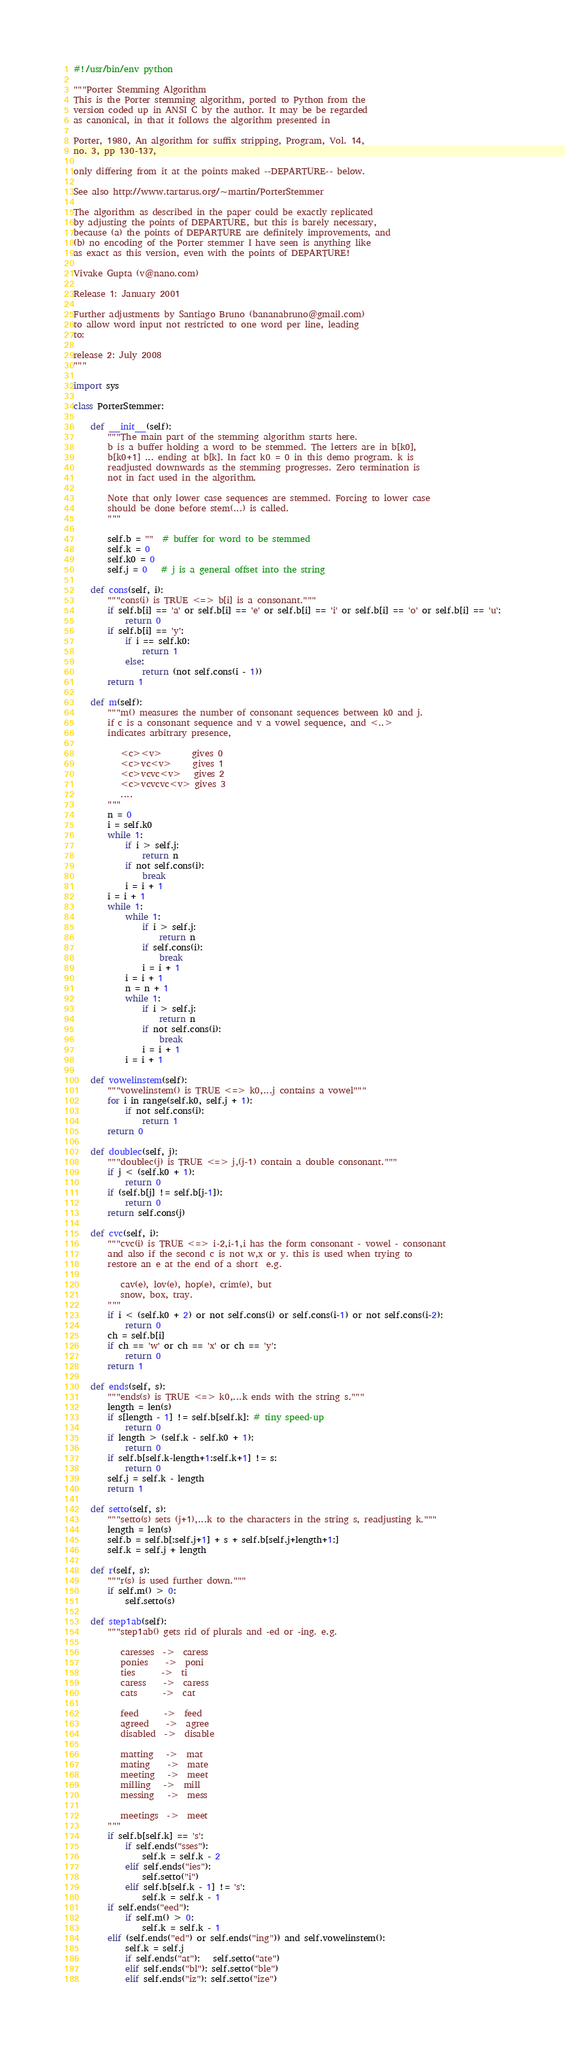Convert code to text. <code><loc_0><loc_0><loc_500><loc_500><_Python_>#!/usr/bin/env python

"""Porter Stemming Algorithm
This is the Porter stemming algorithm, ported to Python from the
version coded up in ANSI C by the author. It may be be regarded
as canonical, in that it follows the algorithm presented in

Porter, 1980, An algorithm for suffix stripping, Program, Vol. 14,
no. 3, pp 130-137,

only differing from it at the points maked --DEPARTURE-- below.

See also http://www.tartarus.org/~martin/PorterStemmer

The algorithm as described in the paper could be exactly replicated
by adjusting the points of DEPARTURE, but this is barely necessary,
because (a) the points of DEPARTURE are definitely improvements, and
(b) no encoding of the Porter stemmer I have seen is anything like
as exact as this version, even with the points of DEPARTURE!

Vivake Gupta (v@nano.com)

Release 1: January 2001

Further adjustments by Santiago Bruno (bananabruno@gmail.com)
to allow word input not restricted to one word per line, leading
to:

release 2: July 2008
"""

import sys

class PorterStemmer:

    def __init__(self):
        """The main part of the stemming algorithm starts here.
        b is a buffer holding a word to be stemmed. The letters are in b[k0],
        b[k0+1] ... ending at b[k]. In fact k0 = 0 in this demo program. k is
        readjusted downwards as the stemming progresses. Zero termination is
        not in fact used in the algorithm.

        Note that only lower case sequences are stemmed. Forcing to lower case
        should be done before stem(...) is called.
        """

        self.b = ""  # buffer for word to be stemmed
        self.k = 0
        self.k0 = 0
        self.j = 0   # j is a general offset into the string

    def cons(self, i):
        """cons(i) is TRUE <=> b[i] is a consonant."""
        if self.b[i] == 'a' or self.b[i] == 'e' or self.b[i] == 'i' or self.b[i] == 'o' or self.b[i] == 'u':
            return 0
        if self.b[i] == 'y':
            if i == self.k0:
                return 1
            else:
                return (not self.cons(i - 1))
        return 1

    def m(self):
        """m() measures the number of consonant sequences between k0 and j.
        if c is a consonant sequence and v a vowel sequence, and <..>
        indicates arbitrary presence,

           <c><v>       gives 0
           <c>vc<v>     gives 1
           <c>vcvc<v>   gives 2
           <c>vcvcvc<v> gives 3
           ....
        """
        n = 0
        i = self.k0
        while 1:
            if i > self.j:
                return n
            if not self.cons(i):
                break
            i = i + 1
        i = i + 1
        while 1:
            while 1:
                if i > self.j:
                    return n
                if self.cons(i):
                    break
                i = i + 1
            i = i + 1
            n = n + 1
            while 1:
                if i > self.j:
                    return n
                if not self.cons(i):
                    break
                i = i + 1
            i = i + 1

    def vowelinstem(self):
        """vowelinstem() is TRUE <=> k0,...j contains a vowel"""
        for i in range(self.k0, self.j + 1):
            if not self.cons(i):
                return 1
        return 0

    def doublec(self, j):
        """doublec(j) is TRUE <=> j,(j-1) contain a double consonant."""
        if j < (self.k0 + 1):
            return 0
        if (self.b[j] != self.b[j-1]):
            return 0
        return self.cons(j)

    def cvc(self, i):
        """cvc(i) is TRUE <=> i-2,i-1,i has the form consonant - vowel - consonant
        and also if the second c is not w,x or y. this is used when trying to
        restore an e at the end of a short  e.g.

           cav(e), lov(e), hop(e), crim(e), but
           snow, box, tray.
        """
        if i < (self.k0 + 2) or not self.cons(i) or self.cons(i-1) or not self.cons(i-2):
            return 0
        ch = self.b[i]
        if ch == 'w' or ch == 'x' or ch == 'y':
            return 0
        return 1

    def ends(self, s):
        """ends(s) is TRUE <=> k0,...k ends with the string s."""
        length = len(s)
        if s[length - 1] != self.b[self.k]: # tiny speed-up
            return 0
        if length > (self.k - self.k0 + 1):
            return 0
        if self.b[self.k-length+1:self.k+1] != s:
            return 0
        self.j = self.k - length
        return 1

    def setto(self, s):
        """setto(s) sets (j+1),...k to the characters in the string s, readjusting k."""
        length = len(s)
        self.b = self.b[:self.j+1] + s + self.b[self.j+length+1:]
        self.k = self.j + length

    def r(self, s):
        """r(s) is used further down."""
        if self.m() > 0:
            self.setto(s)

    def step1ab(self):
        """step1ab() gets rid of plurals and -ed or -ing. e.g.

           caresses  ->  caress
           ponies    ->  poni
           ties      ->  ti
           caress    ->  caress
           cats      ->  cat

           feed      ->  feed
           agreed    ->  agree
           disabled  ->  disable

           matting   ->  mat
           mating    ->  mate
           meeting   ->  meet
           milling   ->  mill
           messing   ->  mess

           meetings  ->  meet
        """
        if self.b[self.k] == 's':
            if self.ends("sses"):
                self.k = self.k - 2
            elif self.ends("ies"):
                self.setto("i")
            elif self.b[self.k - 1] != 's':
                self.k = self.k - 1
        if self.ends("eed"):
            if self.m() > 0:
                self.k = self.k - 1
        elif (self.ends("ed") or self.ends("ing")) and self.vowelinstem():
            self.k = self.j
            if self.ends("at"):   self.setto("ate")
            elif self.ends("bl"): self.setto("ble")
            elif self.ends("iz"): self.setto("ize")</code> 